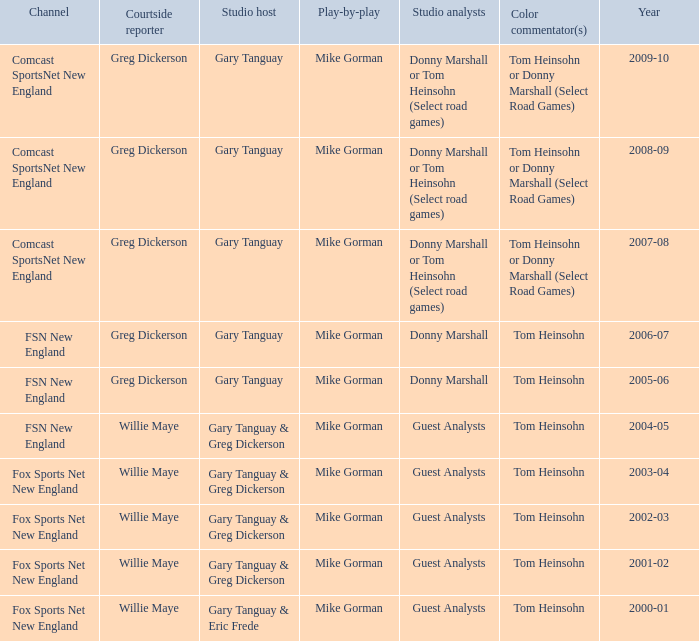WHich Studio analysts has a Studio host of gary tanguay in 2009-10? Donny Marshall or Tom Heinsohn (Select road games). 